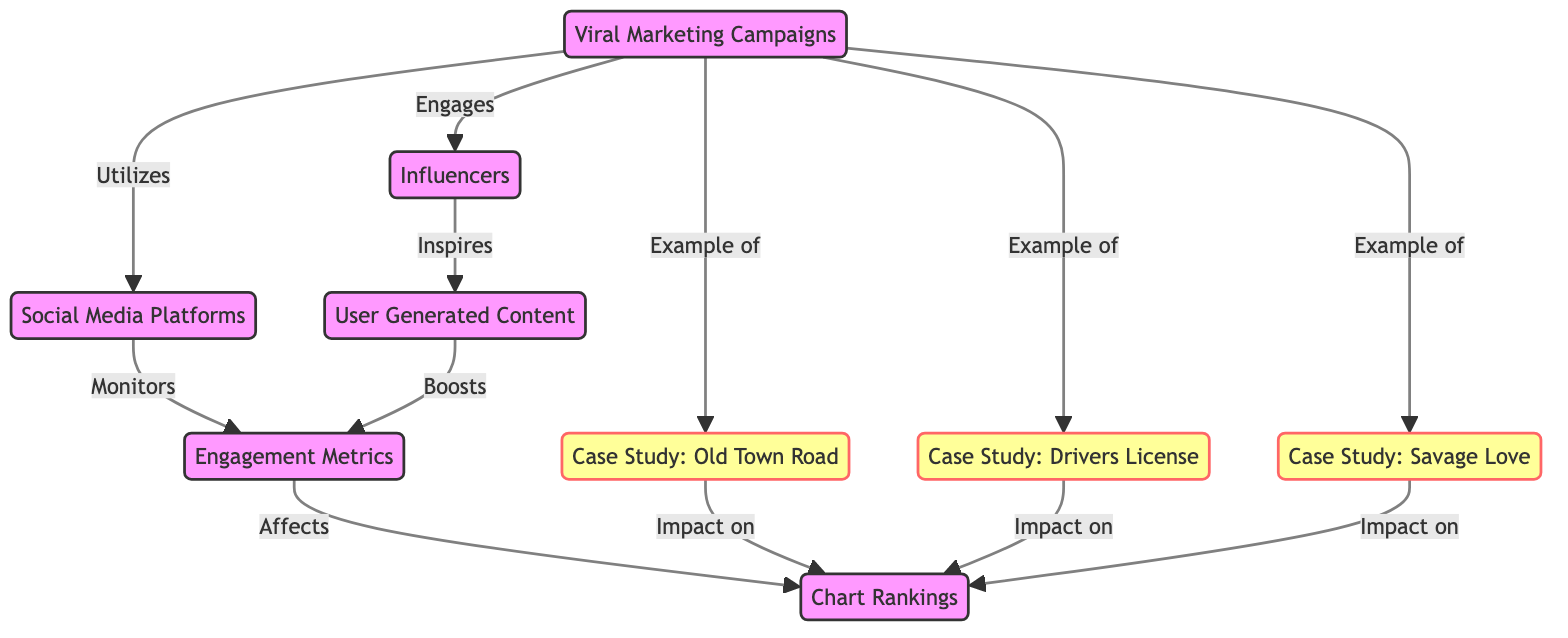What are the main components of Viral Marketing Campaigns? The main components of Viral Marketing Campaigns include Social Media Platforms, Influencers, Engagement Metrics, and User Generated Content. These elements interact to shape the campaign's overall efficacy.
Answer: Social Media Platforms, Influencers, Engagement Metrics, User Generated Content How many case studies are represented in the diagram? The diagram includes three case studies, identified as Old Town Road, Drivers License, and Savage Love. Each is linked to the Viral Marketing Campaigns.
Answer: Three What is the relationship between Engagement Metrics and Chart Rankings? Engagement Metrics directly affect Chart Rankings, which is shown by the arrow indicating a causal relationship from ENG to CHR in the diagram.
Answer: Affects Which case study links to Viral Marketing Campaigns? All three case studies—Old Town Road, Drivers License, and Savage Love—link to Viral Marketing Campaigns as examples, showing their relevance to the campaign’s context.
Answer: Old Town Road, Drivers License, Savage Love What influences User Generated Content according to the diagram? User Generated Content is inspired by Influencers, connecting these two components through an arrow. This illustrates that influencer engagement can lead to a rise in user-generated engagements.
Answer: Influencers How does User Generated Content influence Engagement Metrics? User Generated Content boosts Engagement Metrics, as depicted in the diagram by an arrow connecting UGC to ENG, indicating a positive influence on engagement levels.
Answer: Boosts What is the effect of Social Media Platforms on Engagement Metrics? Social Media Platforms monitor Engagement Metrics according to the diagram, suggesting that platform activities help analyze and track engagement data associated with campaigns.
Answer: Monitors Which component serves as an intermediary between Influencers and Chart Rankings? Engagement Metrics serve as an intermediary; they affect Chart Rankings while being influenced by both Social Media Platforms and User Generated Content. This indicates a layered influence structure.
Answer: Engagement Metrics What does Viral Marketing Campaigns utilize? Viral Marketing Campaigns utilize Social Media Platforms to effectively reach broader audiences and promote content, as indicated by the direct connection in the diagram.
Answer: Social Media Platforms 